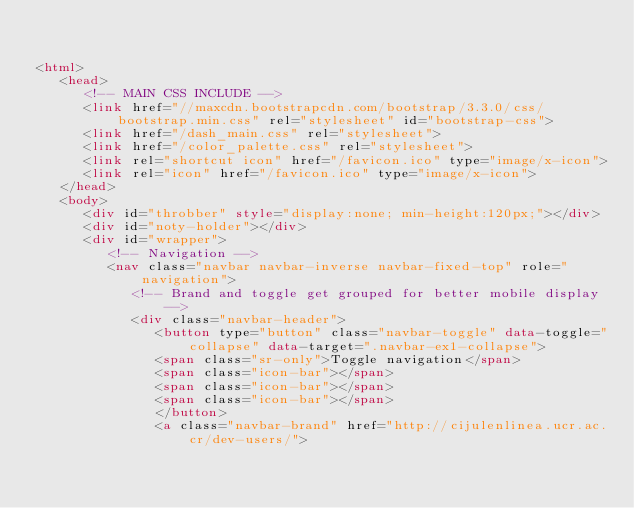<code> <loc_0><loc_0><loc_500><loc_500><_HTML_>

<html>
   <head>
      <!-- MAIN CSS INCLUDE -->
      <link href="//maxcdn.bootstrapcdn.com/bootstrap/3.3.0/css/bootstrap.min.css" rel="stylesheet" id="bootstrap-css">
      <link href="/dash_main.css" rel="stylesheet">
      <link href="/color_palette.css" rel="stylesheet">
      <link rel="shortcut icon" href="/favicon.ico" type="image/x-icon">
      <link rel="icon" href="/favicon.ico" type="image/x-icon">
   </head>
   <body>
      <div id="throbber" style="display:none; min-height:120px;"></div>
      <div id="noty-holder"></div>
      <div id="wrapper">
         <!-- Navigation -->
         <nav class="navbar navbar-inverse navbar-fixed-top" role="navigation">
            <!-- Brand and toggle get grouped for better mobile display -->
            <div class="navbar-header">
               <button type="button" class="navbar-toggle" data-toggle="collapse" data-target=".navbar-ex1-collapse">
               <span class="sr-only">Toggle navigation</span>
               <span class="icon-bar"></span>
               <span class="icon-bar"></span>
               <span class="icon-bar"></span>
               </button>
               <a class="navbar-brand" href="http://cijulenlinea.ucr.ac.cr/dev-users/"></code> 